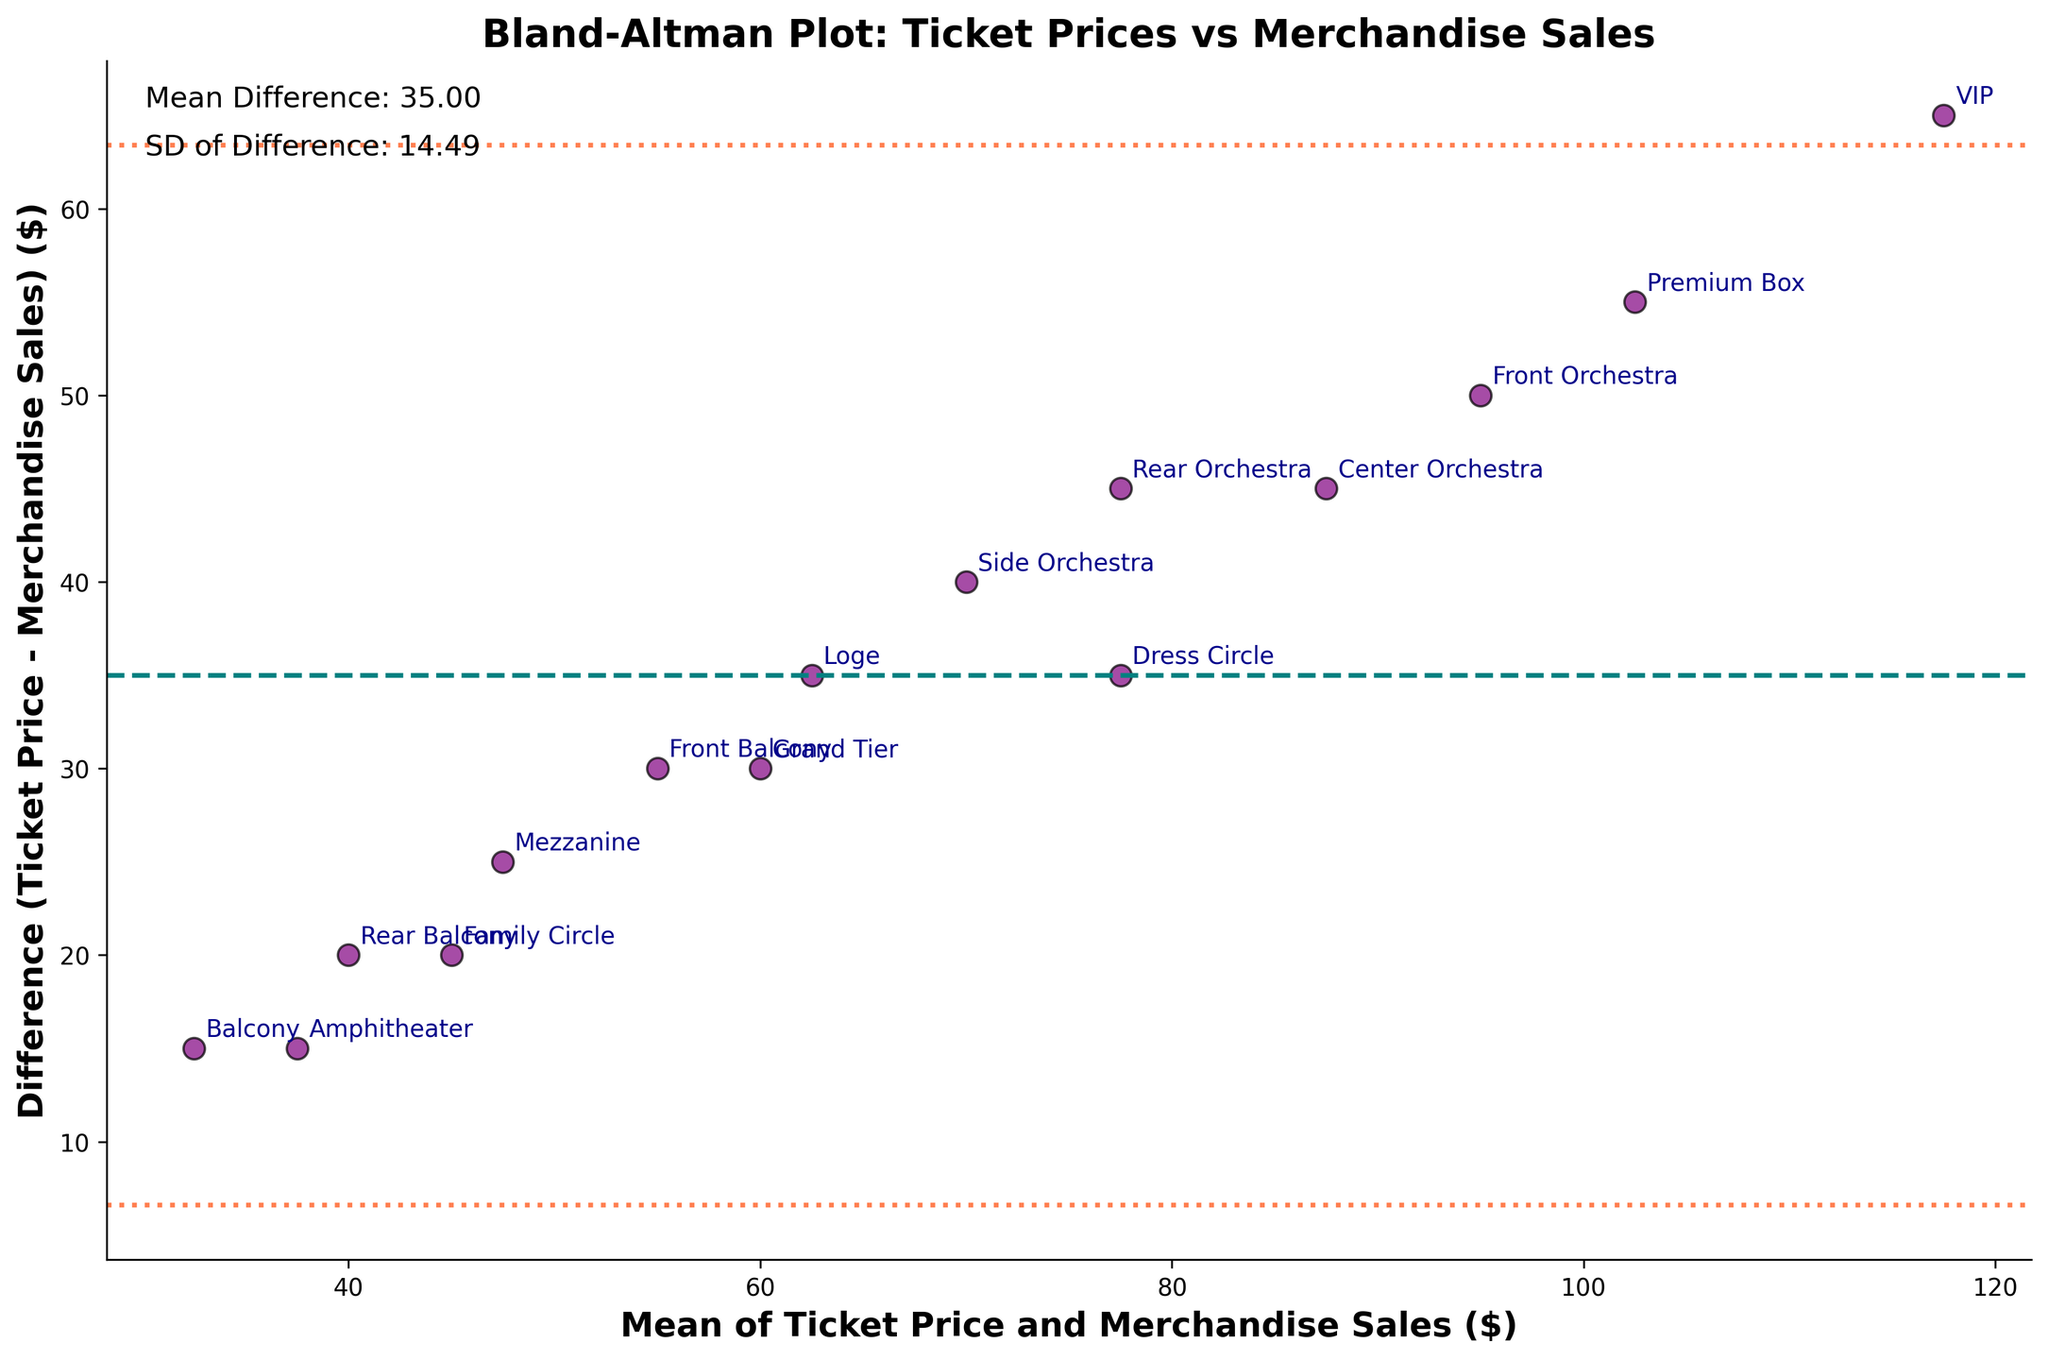How many data points are shown in the figure? There are markers for each seating section in the scatter plot. Each section corresponds to a data point. Counting these markers gives us the total number of data points.
Answer: 15 What do the dashed line and dotted lines represent? The dashed line represents the mean difference between ticket prices and merchandise sales. The dotted lines represent the limits of agreement, which are the mean difference ± 1.96 times the standard deviation of the differences.
Answer: Mean difference and limits of agreement Which seating section has the highest difference between ticket prices and merchandise sales? By observing the vertical distance on the plot, VIP has the highest positive difference (the farthest point above the dashed line), indicating that its ticket prices are much higher relative to its merchandise sales.
Answer: VIP What's the mean difference observed in the plot? The plot includes a text annotation indicating the mean difference, placed near the top left of the figure.
Answer: 45.0 How does the standard deviation of differences compare to the mean difference? The plot contains a text annotation showing the standard deviation of differences. You compare this value with the mean difference value also annotated on the plot.
Answer: SD is smaller than the mean difference What is the approximate value of the lower limit of agreement? The lower limit of agreement is shown as the lower dotted line, calculated as the mean difference minus 1.96 times the standard deviation. By referring to the text annotations for the mean difference (45) and the standard deviation (12.99), compute 45 - 1.96*12.99.
Answer: Approximately 19.5 Is there any section whose difference value lies outside the limits of agreement? Observing the scatter plot, all data points fall between the upper and lower dotted lines, indicating no outliers outside the limits of agreement.
Answer: No Which seating section shows the closest match between ticket prices and merchandise sales? The section closest to the dashed mean difference line (horizontal axis near zero) has the smallest difference. The Mezzanine section is closest to this line.
Answer: Mezzanine How many sections exhibit a positive difference, indicating higher ticket prices compared to merchandise sales? Positive differences appear as points above the horizontal dashed line. Counting these specific points provides the answer.
Answer: 8 What's the approximate upper limit of agreement? The upper limit of agreement is the upper dotted line. It is calculated by adding 1.96 times the standard deviation to the mean difference. Using the provided values from the annotations: 45 + 1.96*12.99.
Answer: Approximately 70.5 